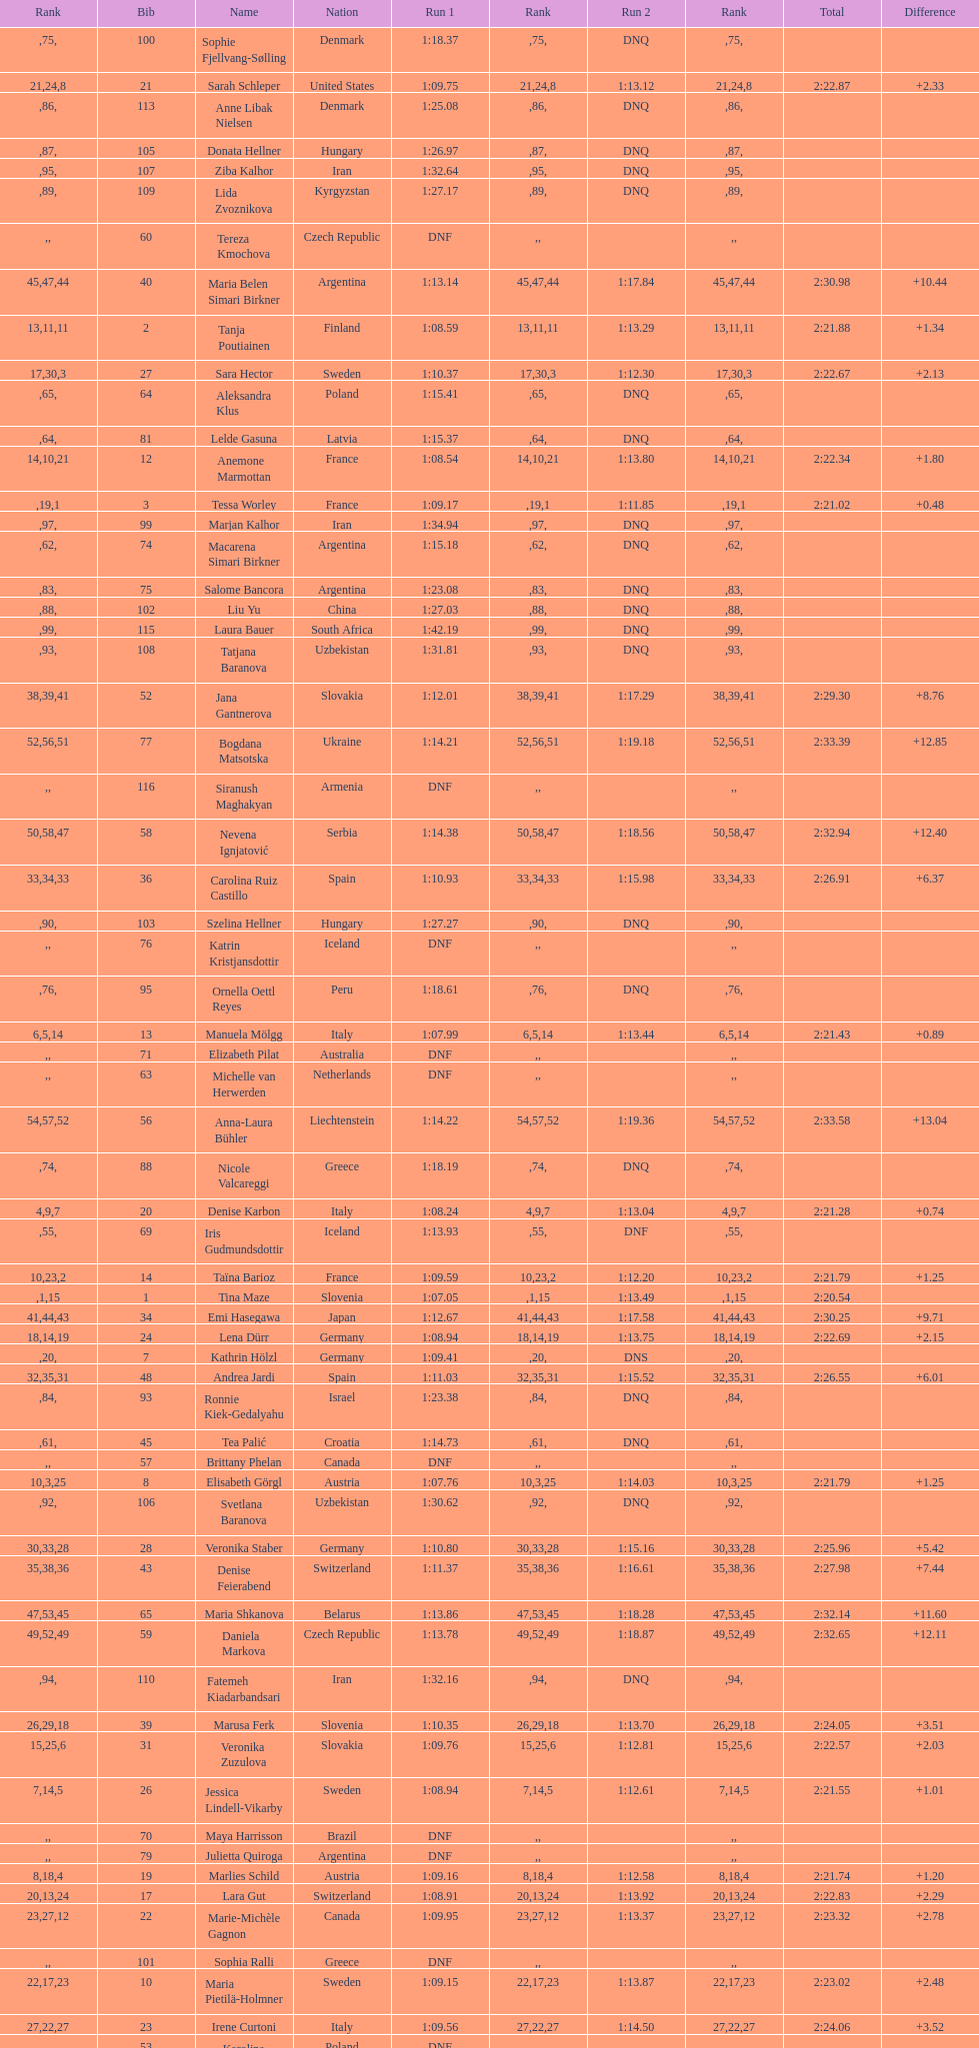Which name comes before anja parson? Marlies Schild. 